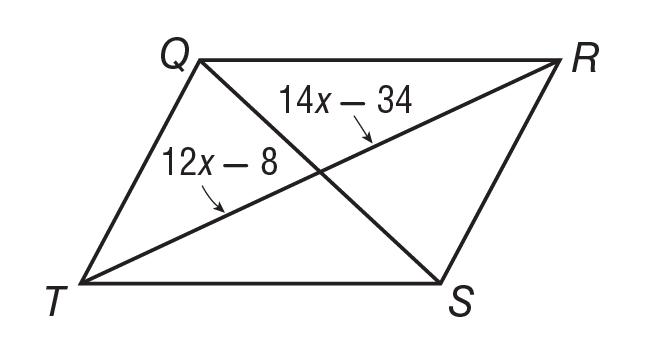Question: If Q R S T is a parallelogram, what is the value of x?
Choices:
A. 11
B. 12
C. 13
D. 14
Answer with the letter. Answer: C 